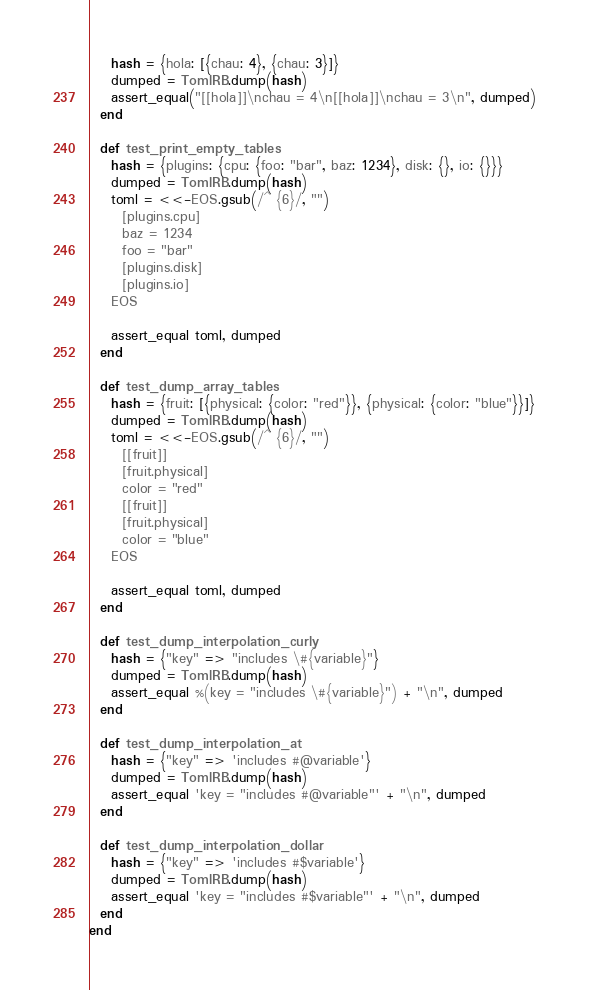Convert code to text. <code><loc_0><loc_0><loc_500><loc_500><_Ruby_>    hash = {hola: [{chau: 4}, {chau: 3}]}
    dumped = TomlRB.dump(hash)
    assert_equal("[[hola]]\nchau = 4\n[[hola]]\nchau = 3\n", dumped)
  end

  def test_print_empty_tables
    hash = {plugins: {cpu: {foo: "bar", baz: 1234}, disk: {}, io: {}}}
    dumped = TomlRB.dump(hash)
    toml = <<-EOS.gsub(/^ {6}/, "")
      [plugins.cpu]
      baz = 1234
      foo = "bar"
      [plugins.disk]
      [plugins.io]
    EOS

    assert_equal toml, dumped
  end

  def test_dump_array_tables
    hash = {fruit: [{physical: {color: "red"}}, {physical: {color: "blue"}}]}
    dumped = TomlRB.dump(hash)
    toml = <<-EOS.gsub(/^ {6}/, "")
      [[fruit]]
      [fruit.physical]
      color = "red"
      [[fruit]]
      [fruit.physical]
      color = "blue"
    EOS

    assert_equal toml, dumped
  end

  def test_dump_interpolation_curly
    hash = {"key" => "includes \#{variable}"}
    dumped = TomlRB.dump(hash)
    assert_equal %(key = "includes \#{variable}") + "\n", dumped
  end

  def test_dump_interpolation_at
    hash = {"key" => 'includes #@variable'}
    dumped = TomlRB.dump(hash)
    assert_equal 'key = "includes #@variable"' + "\n", dumped
  end

  def test_dump_interpolation_dollar
    hash = {"key" => 'includes #$variable'}
    dumped = TomlRB.dump(hash)
    assert_equal 'key = "includes #$variable"' + "\n", dumped
  end
end
</code> 